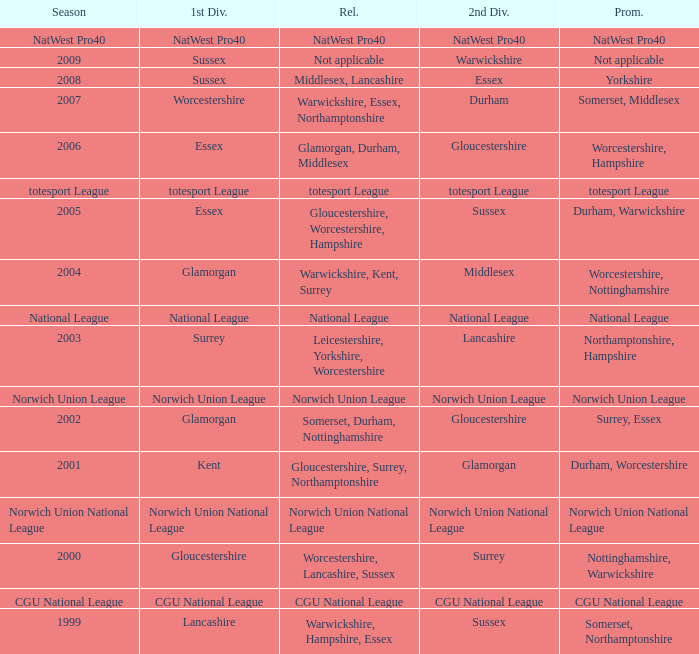What is the 1st division when the 2nd division is national league? National League. 